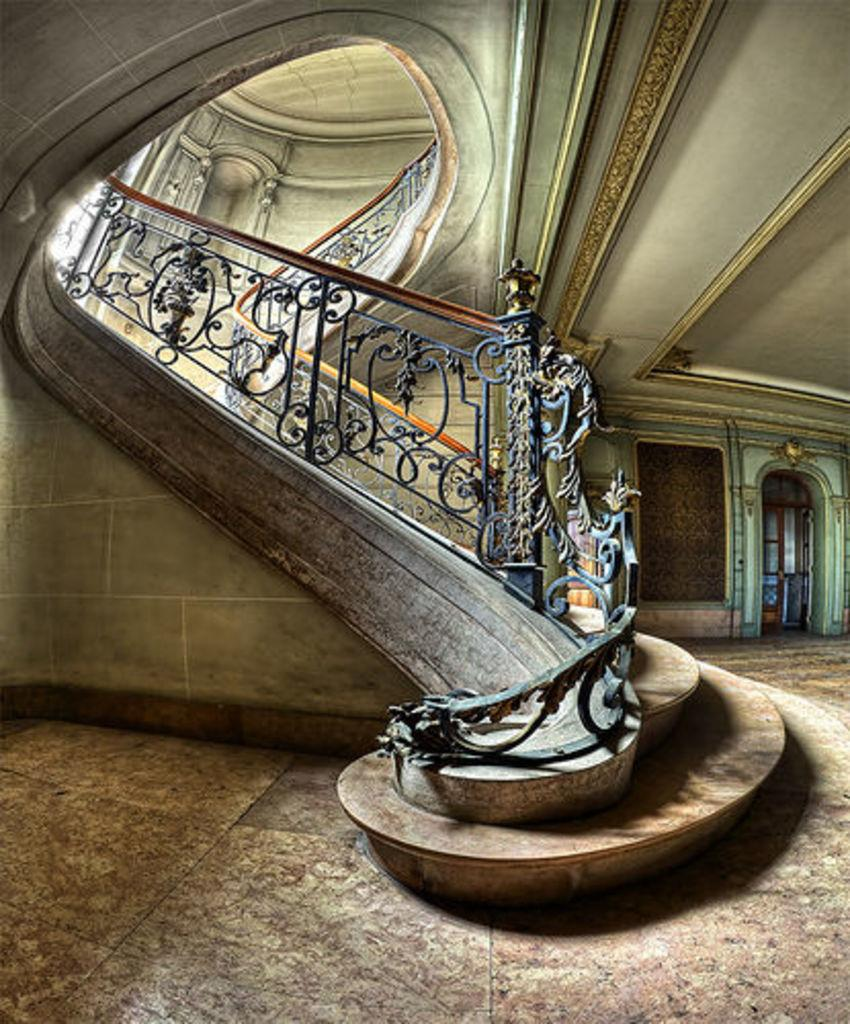What type of location is depicted in the image? The image shows an inside view of a building. What architectural feature can be seen in the image? There are stairs visible in the image. Is there any entrance or exit visible in the image? Yes, there is a door in the image. What type of jar can be seen floating in a bubble in the wilderness in the image? There is no jar, bubble, or wilderness present in the image. 